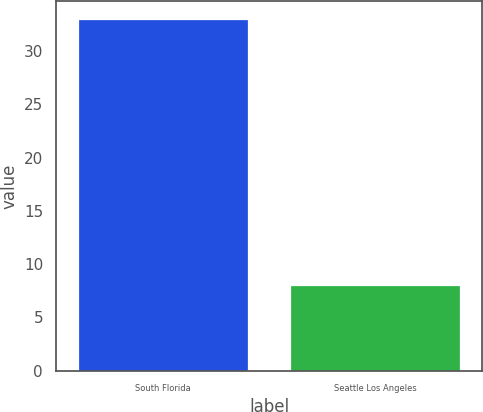Convert chart to OTSL. <chart><loc_0><loc_0><loc_500><loc_500><bar_chart><fcel>South Florida<fcel>Seattle Los Angeles<nl><fcel>33<fcel>8<nl></chart> 